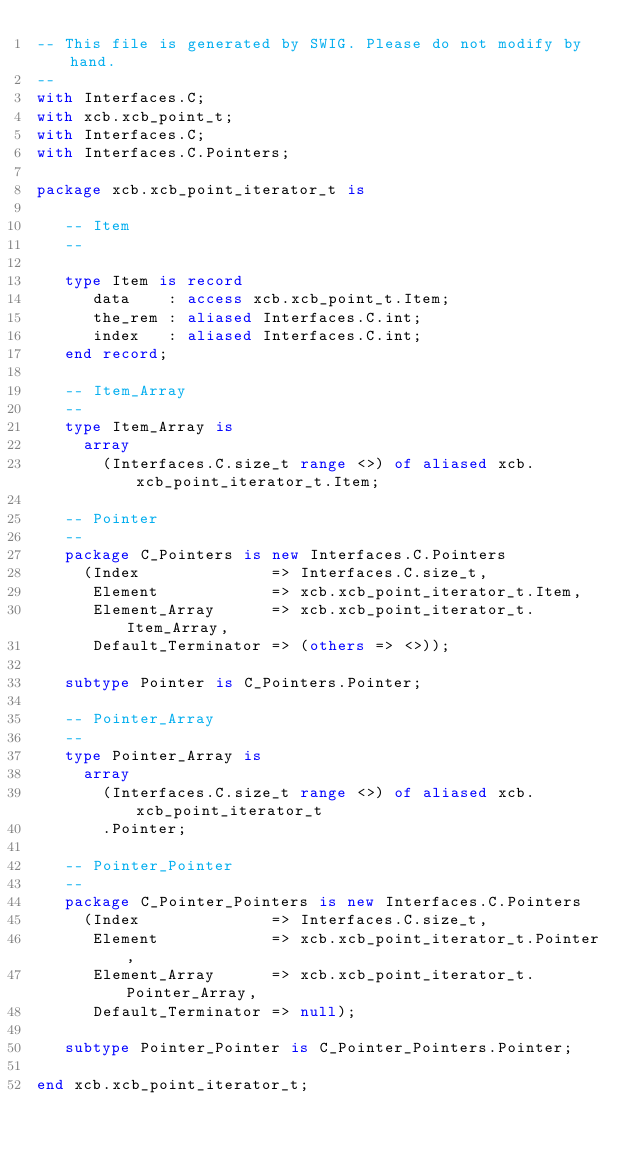<code> <loc_0><loc_0><loc_500><loc_500><_Ada_>-- This file is generated by SWIG. Please do not modify by hand.
--
with Interfaces.C;
with xcb.xcb_point_t;
with Interfaces.C;
with Interfaces.C.Pointers;

package xcb.xcb_point_iterator_t is

   -- Item
   --

   type Item is record
      data    : access xcb.xcb_point_t.Item;
      the_rem : aliased Interfaces.C.int;
      index   : aliased Interfaces.C.int;
   end record;

   -- Item_Array
   --
   type Item_Array is
     array
       (Interfaces.C.size_t range <>) of aliased xcb.xcb_point_iterator_t.Item;

   -- Pointer
   --
   package C_Pointers is new Interfaces.C.Pointers
     (Index              => Interfaces.C.size_t,
      Element            => xcb.xcb_point_iterator_t.Item,
      Element_Array      => xcb.xcb_point_iterator_t.Item_Array,
      Default_Terminator => (others => <>));

   subtype Pointer is C_Pointers.Pointer;

   -- Pointer_Array
   --
   type Pointer_Array is
     array
       (Interfaces.C.size_t range <>) of aliased xcb.xcb_point_iterator_t
       .Pointer;

   -- Pointer_Pointer
   --
   package C_Pointer_Pointers is new Interfaces.C.Pointers
     (Index              => Interfaces.C.size_t,
      Element            => xcb.xcb_point_iterator_t.Pointer,
      Element_Array      => xcb.xcb_point_iterator_t.Pointer_Array,
      Default_Terminator => null);

   subtype Pointer_Pointer is C_Pointer_Pointers.Pointer;

end xcb.xcb_point_iterator_t;
</code> 